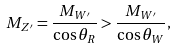Convert formula to latex. <formula><loc_0><loc_0><loc_500><loc_500>M _ { Z ^ { \prime } } = \frac { M _ { W ^ { \prime } } } { \cos \theta _ { R } } > \frac { M _ { W ^ { \prime } } } { \cos \theta _ { W } } ,</formula> 